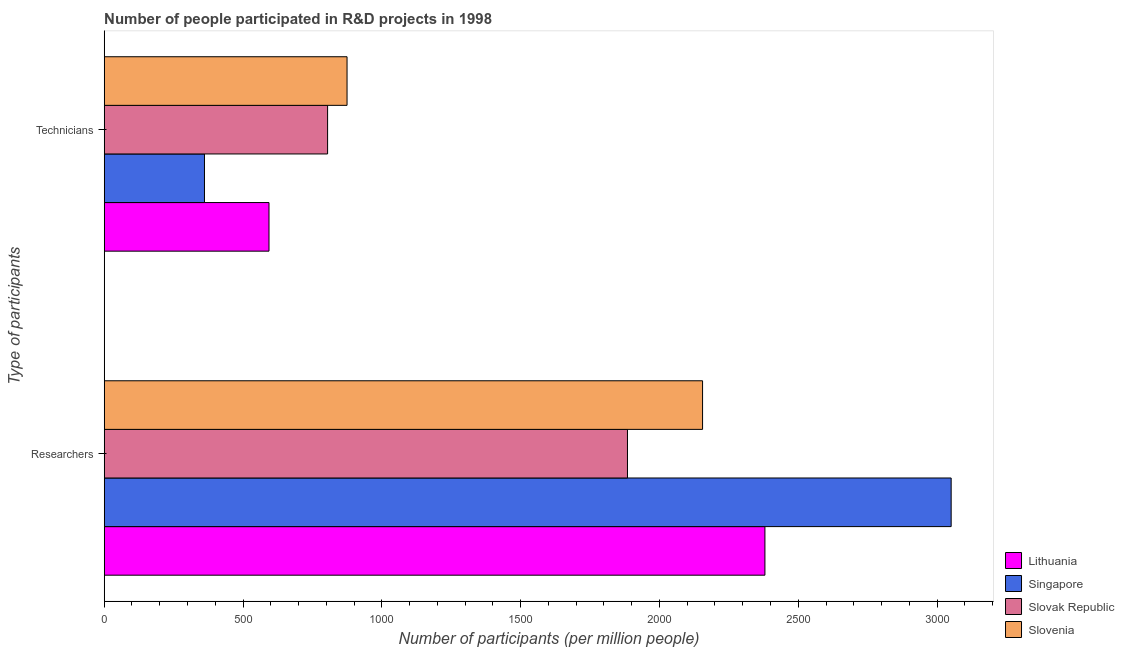How many different coloured bars are there?
Make the answer very short. 4. How many bars are there on the 1st tick from the bottom?
Provide a short and direct response. 4. What is the label of the 1st group of bars from the top?
Keep it short and to the point. Technicians. What is the number of researchers in Slovak Republic?
Your response must be concise. 1884.8. Across all countries, what is the maximum number of researchers?
Make the answer very short. 3050.73. Across all countries, what is the minimum number of researchers?
Provide a succinct answer. 1884.8. In which country was the number of technicians maximum?
Ensure brevity in your answer.  Slovenia. In which country was the number of researchers minimum?
Provide a short and direct response. Slovak Republic. What is the total number of technicians in the graph?
Make the answer very short. 2634.04. What is the difference between the number of researchers in Slovenia and that in Slovak Republic?
Offer a very short reply. 270.45. What is the difference between the number of technicians in Lithuania and the number of researchers in Singapore?
Provide a succinct answer. -2457.16. What is the average number of technicians per country?
Provide a short and direct response. 658.51. What is the difference between the number of technicians and number of researchers in Lithuania?
Give a very brief answer. -1786.35. What is the ratio of the number of researchers in Singapore to that in Lithuania?
Offer a terse response. 1.28. In how many countries, is the number of technicians greater than the average number of technicians taken over all countries?
Ensure brevity in your answer.  2. What does the 3rd bar from the top in Researchers represents?
Offer a terse response. Singapore. What does the 4th bar from the bottom in Researchers represents?
Your response must be concise. Slovenia. What is the difference between two consecutive major ticks on the X-axis?
Provide a succinct answer. 500. Does the graph contain any zero values?
Your answer should be compact. No. Does the graph contain grids?
Offer a terse response. No. Where does the legend appear in the graph?
Offer a very short reply. Bottom right. How many legend labels are there?
Offer a terse response. 4. How are the legend labels stacked?
Offer a terse response. Vertical. What is the title of the graph?
Give a very brief answer. Number of people participated in R&D projects in 1998. What is the label or title of the X-axis?
Offer a terse response. Number of participants (per million people). What is the label or title of the Y-axis?
Offer a very short reply. Type of participants. What is the Number of participants (per million people) of Lithuania in Researchers?
Your answer should be compact. 2379.91. What is the Number of participants (per million people) of Singapore in Researchers?
Offer a very short reply. 3050.73. What is the Number of participants (per million people) of Slovak Republic in Researchers?
Offer a terse response. 1884.8. What is the Number of participants (per million people) of Slovenia in Researchers?
Ensure brevity in your answer.  2155.25. What is the Number of participants (per million people) in Lithuania in Technicians?
Provide a short and direct response. 593.57. What is the Number of participants (per million people) in Singapore in Technicians?
Your answer should be very brief. 361.15. What is the Number of participants (per million people) in Slovak Republic in Technicians?
Ensure brevity in your answer.  804.64. What is the Number of participants (per million people) of Slovenia in Technicians?
Provide a short and direct response. 874.68. Across all Type of participants, what is the maximum Number of participants (per million people) in Lithuania?
Make the answer very short. 2379.91. Across all Type of participants, what is the maximum Number of participants (per million people) in Singapore?
Provide a succinct answer. 3050.73. Across all Type of participants, what is the maximum Number of participants (per million people) of Slovak Republic?
Your answer should be compact. 1884.8. Across all Type of participants, what is the maximum Number of participants (per million people) of Slovenia?
Keep it short and to the point. 2155.25. Across all Type of participants, what is the minimum Number of participants (per million people) of Lithuania?
Your answer should be very brief. 593.57. Across all Type of participants, what is the minimum Number of participants (per million people) of Singapore?
Your answer should be compact. 361.15. Across all Type of participants, what is the minimum Number of participants (per million people) in Slovak Republic?
Your response must be concise. 804.64. Across all Type of participants, what is the minimum Number of participants (per million people) of Slovenia?
Keep it short and to the point. 874.68. What is the total Number of participants (per million people) in Lithuania in the graph?
Ensure brevity in your answer.  2973.48. What is the total Number of participants (per million people) in Singapore in the graph?
Your answer should be very brief. 3411.88. What is the total Number of participants (per million people) of Slovak Republic in the graph?
Give a very brief answer. 2689.45. What is the total Number of participants (per million people) in Slovenia in the graph?
Offer a very short reply. 3029.93. What is the difference between the Number of participants (per million people) of Lithuania in Researchers and that in Technicians?
Offer a terse response. 1786.35. What is the difference between the Number of participants (per million people) in Singapore in Researchers and that in Technicians?
Provide a short and direct response. 2689.58. What is the difference between the Number of participants (per million people) of Slovak Republic in Researchers and that in Technicians?
Your response must be concise. 1080.16. What is the difference between the Number of participants (per million people) in Slovenia in Researchers and that in Technicians?
Provide a succinct answer. 1280.58. What is the difference between the Number of participants (per million people) in Lithuania in Researchers and the Number of participants (per million people) in Singapore in Technicians?
Ensure brevity in your answer.  2018.76. What is the difference between the Number of participants (per million people) in Lithuania in Researchers and the Number of participants (per million people) in Slovak Republic in Technicians?
Offer a terse response. 1575.27. What is the difference between the Number of participants (per million people) in Lithuania in Researchers and the Number of participants (per million people) in Slovenia in Technicians?
Give a very brief answer. 1505.24. What is the difference between the Number of participants (per million people) of Singapore in Researchers and the Number of participants (per million people) of Slovak Republic in Technicians?
Your answer should be compact. 2246.09. What is the difference between the Number of participants (per million people) of Singapore in Researchers and the Number of participants (per million people) of Slovenia in Technicians?
Provide a succinct answer. 2176.06. What is the difference between the Number of participants (per million people) in Slovak Republic in Researchers and the Number of participants (per million people) in Slovenia in Technicians?
Offer a terse response. 1010.13. What is the average Number of participants (per million people) of Lithuania per Type of participants?
Your response must be concise. 1486.74. What is the average Number of participants (per million people) in Singapore per Type of participants?
Offer a terse response. 1705.94. What is the average Number of participants (per million people) in Slovak Republic per Type of participants?
Provide a short and direct response. 1344.72. What is the average Number of participants (per million people) in Slovenia per Type of participants?
Your response must be concise. 1514.96. What is the difference between the Number of participants (per million people) of Lithuania and Number of participants (per million people) of Singapore in Researchers?
Make the answer very short. -670.82. What is the difference between the Number of participants (per million people) in Lithuania and Number of participants (per million people) in Slovak Republic in Researchers?
Ensure brevity in your answer.  495.11. What is the difference between the Number of participants (per million people) of Lithuania and Number of participants (per million people) of Slovenia in Researchers?
Offer a terse response. 224.66. What is the difference between the Number of participants (per million people) of Singapore and Number of participants (per million people) of Slovak Republic in Researchers?
Your answer should be very brief. 1165.93. What is the difference between the Number of participants (per million people) of Singapore and Number of participants (per million people) of Slovenia in Researchers?
Make the answer very short. 895.48. What is the difference between the Number of participants (per million people) of Slovak Republic and Number of participants (per million people) of Slovenia in Researchers?
Provide a succinct answer. -270.45. What is the difference between the Number of participants (per million people) of Lithuania and Number of participants (per million people) of Singapore in Technicians?
Your response must be concise. 232.41. What is the difference between the Number of participants (per million people) of Lithuania and Number of participants (per million people) of Slovak Republic in Technicians?
Provide a succinct answer. -211.07. What is the difference between the Number of participants (per million people) of Lithuania and Number of participants (per million people) of Slovenia in Technicians?
Your response must be concise. -281.11. What is the difference between the Number of participants (per million people) of Singapore and Number of participants (per million people) of Slovak Republic in Technicians?
Make the answer very short. -443.49. What is the difference between the Number of participants (per million people) in Singapore and Number of participants (per million people) in Slovenia in Technicians?
Provide a succinct answer. -513.52. What is the difference between the Number of participants (per million people) in Slovak Republic and Number of participants (per million people) in Slovenia in Technicians?
Keep it short and to the point. -70.03. What is the ratio of the Number of participants (per million people) in Lithuania in Researchers to that in Technicians?
Your answer should be compact. 4.01. What is the ratio of the Number of participants (per million people) of Singapore in Researchers to that in Technicians?
Provide a succinct answer. 8.45. What is the ratio of the Number of participants (per million people) in Slovak Republic in Researchers to that in Technicians?
Ensure brevity in your answer.  2.34. What is the ratio of the Number of participants (per million people) in Slovenia in Researchers to that in Technicians?
Your answer should be compact. 2.46. What is the difference between the highest and the second highest Number of participants (per million people) of Lithuania?
Make the answer very short. 1786.35. What is the difference between the highest and the second highest Number of participants (per million people) of Singapore?
Provide a succinct answer. 2689.58. What is the difference between the highest and the second highest Number of participants (per million people) in Slovak Republic?
Your answer should be compact. 1080.16. What is the difference between the highest and the second highest Number of participants (per million people) in Slovenia?
Offer a very short reply. 1280.58. What is the difference between the highest and the lowest Number of participants (per million people) of Lithuania?
Your answer should be very brief. 1786.35. What is the difference between the highest and the lowest Number of participants (per million people) in Singapore?
Provide a short and direct response. 2689.58. What is the difference between the highest and the lowest Number of participants (per million people) in Slovak Republic?
Provide a short and direct response. 1080.16. What is the difference between the highest and the lowest Number of participants (per million people) in Slovenia?
Offer a very short reply. 1280.58. 